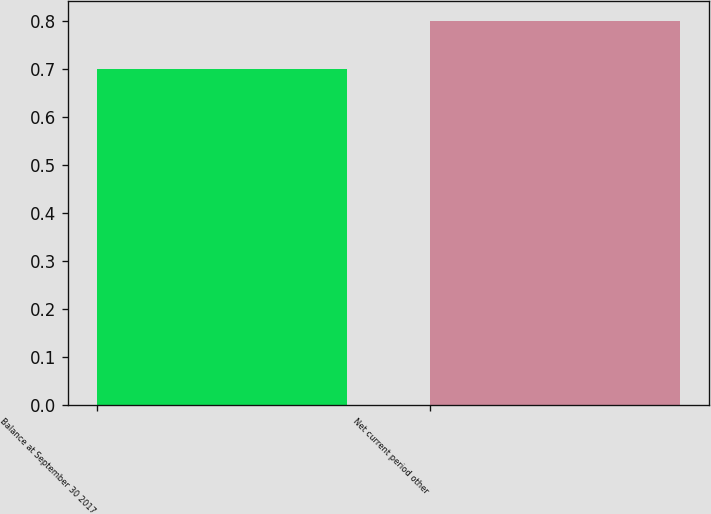<chart> <loc_0><loc_0><loc_500><loc_500><bar_chart><fcel>Balance at September 30 2017<fcel>Net current period other<nl><fcel>0.7<fcel>0.8<nl></chart> 